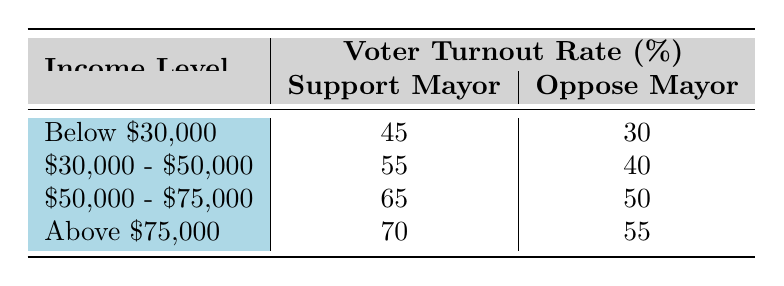What is the voter turnout rate for individuals with an income level of Below $30,000 who support the mayor? The table indicates that for individuals with an income level of Below $30,000 who support the mayor, the turnout rate is 45%.
Answer: 45 What is the voter turnout rate for those who oppose the mayor in the income level of $50,000 - $75,000? According to the table, the turnout rate for those who oppose the mayor in the income level of $50,000 - $75,000 is 50%.
Answer: 50 Which income level has the highest voter turnout rate for support of the mayor? The table shows that the income level of Above $75,000 has the highest turnout rate for support of the mayor at 70%.
Answer: Above $75,000 Is the turnout rate for individuals who oppose the mayor higher among those earning $30,000 - $50,000 compared to those earning Below $30,000? The table shows that the turnout rate for opposing the mayor is 40% for the $30,000 - $50,000 group and 30% for the Below $30,000 group. Since 40% is greater than 30%, the answer is yes.
Answer: Yes What is the average voter turnout rate for those who support the mayor across all income levels provided? To find the average, we sum the turnout rates for support (45 + 55 + 65 + 70 = 235) and divide by the number of income levels (4). The average is 235/4 = 58.75.
Answer: 58.75 What is the difference in voter turnout rates between supporters and opposers of the mayor at the income level Above $75,000? The turnout rate for supporters is 70% and for opposers is 55%. The difference is calculated as 70 - 55 = 15.
Answer: 15 Are there more voters in the income bracket of $30,000 - $50,000 who support the mayor compared to those who oppose him? The table states that 55% of those in the $30,000 - $50,000 income range support the mayor, while 40% oppose, indicating more support among this income bracket.
Answer: Yes What is the lowest voter turnout rate among all income levels across both support and opposition to the mayor? Reviewing the turnout rates, the lowest is 30% for individuals earning Below $30,000 who oppose the mayor.
Answer: 30 What is the total voter turnout percentage for all income levels combined when supporting the mayor? The total percent can be added (45 + 55 + 65 + 70 = 235) and this is simply a summation of all support rates across the income levels.
Answer: 235 